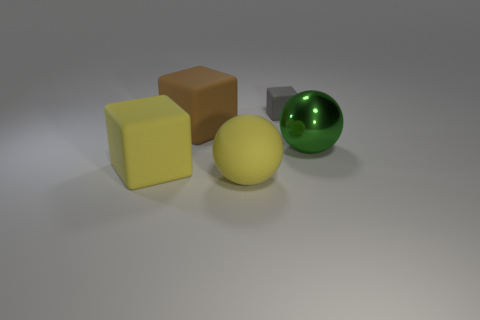Add 2 green metal things. How many objects exist? 7 Subtract all spheres. How many objects are left? 3 Subtract 0 yellow cylinders. How many objects are left? 5 Subtract all big objects. Subtract all cyan shiny spheres. How many objects are left? 1 Add 1 big matte balls. How many big matte balls are left? 2 Add 1 large green metal things. How many large green metal things exist? 2 